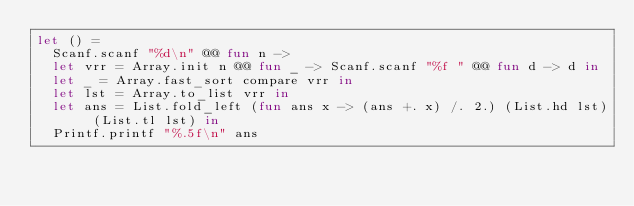Convert code to text. <code><loc_0><loc_0><loc_500><loc_500><_OCaml_>let () =
  Scanf.scanf "%d\n" @@ fun n ->
  let vrr = Array.init n @@ fun _ -> Scanf.scanf "%f " @@ fun d -> d in
  let _ = Array.fast_sort compare vrr in
  let lst = Array.to_list vrr in
  let ans = List.fold_left (fun ans x -> (ans +. x) /. 2.) (List.hd lst) (List.tl lst) in
  Printf.printf "%.5f\n" ans</code> 